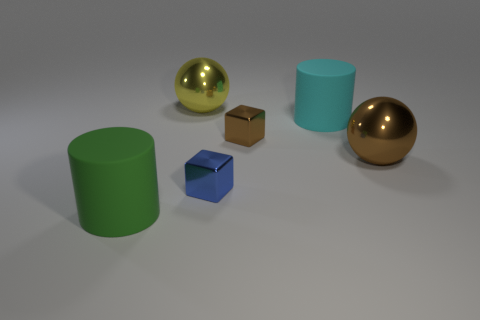Add 4 brown things. How many objects exist? 10 Subtract 1 cylinders. How many cylinders are left? 1 Subtract all blue cubes. How many cubes are left? 1 Subtract all spheres. How many objects are left? 4 Add 3 big green cylinders. How many big green cylinders are left? 4 Add 4 large cyan cylinders. How many large cyan cylinders exist? 5 Subtract 1 brown spheres. How many objects are left? 5 Subtract all blue balls. Subtract all blue blocks. How many balls are left? 2 Subtract all cyan cylinders. Subtract all small cyan objects. How many objects are left? 5 